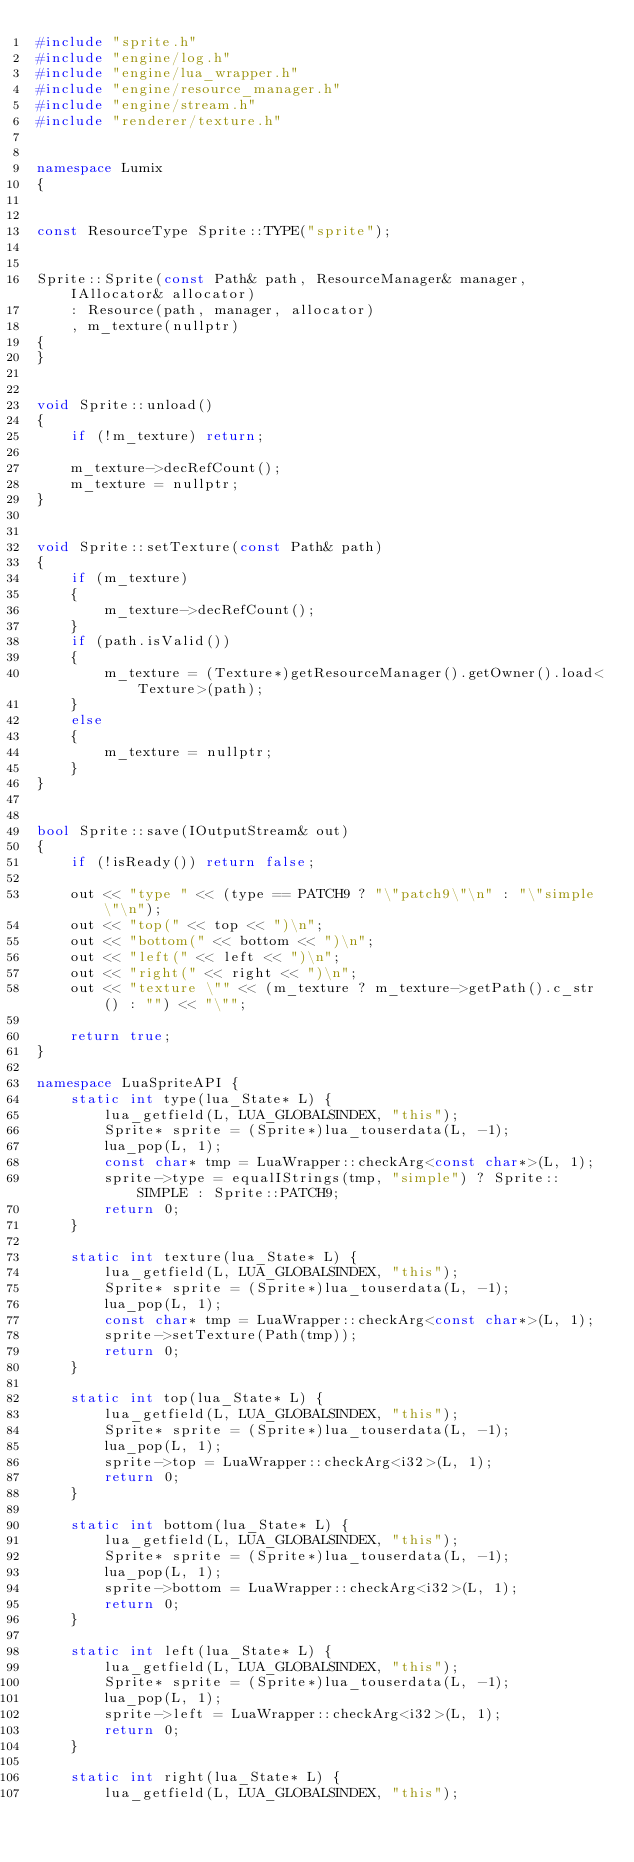Convert code to text. <code><loc_0><loc_0><loc_500><loc_500><_C++_>#include "sprite.h"
#include "engine/log.h"
#include "engine/lua_wrapper.h"
#include "engine/resource_manager.h"
#include "engine/stream.h"
#include "renderer/texture.h"


namespace Lumix
{


const ResourceType Sprite::TYPE("sprite");


Sprite::Sprite(const Path& path, ResourceManager& manager, IAllocator& allocator)
	: Resource(path, manager, allocator)
	, m_texture(nullptr)
{
}


void Sprite::unload()
{
	if (!m_texture) return;
	
	m_texture->decRefCount();
	m_texture = nullptr;
}


void Sprite::setTexture(const Path& path)
{
	if (m_texture)
	{
		m_texture->decRefCount();
	}
	if (path.isValid())
	{
		m_texture = (Texture*)getResourceManager().getOwner().load<Texture>(path);
	}
	else
	{
		m_texture = nullptr;
	}
}


bool Sprite::save(IOutputStream& out)
{
	if (!isReady()) return false;

	out << "type " << (type == PATCH9 ? "\"patch9\"\n" : "\"simple\"\n");
	out << "top(" << top << ")\n";
	out << "bottom(" << bottom << ")\n";
	out << "left(" << left << ")\n";
	out << "right(" << right << ")\n";
	out << "texture \"" << (m_texture ? m_texture->getPath().c_str() : "") << "\"";

	return true;
}

namespace LuaSpriteAPI {
	static int type(lua_State* L) {
		lua_getfield(L, LUA_GLOBALSINDEX, "this");
		Sprite* sprite = (Sprite*)lua_touserdata(L, -1);
		lua_pop(L, 1);
		const char* tmp = LuaWrapper::checkArg<const char*>(L, 1);
		sprite->type = equalIStrings(tmp, "simple") ? Sprite::SIMPLE : Sprite::PATCH9; 
		return 0;
	}

	static int texture(lua_State* L) {
		lua_getfield(L, LUA_GLOBALSINDEX, "this");
		Sprite* sprite = (Sprite*)lua_touserdata(L, -1);
		lua_pop(L, 1);
		const char* tmp = LuaWrapper::checkArg<const char*>(L, 1);
		sprite->setTexture(Path(tmp));
		return 0;
	}

	static int top(lua_State* L) {
		lua_getfield(L, LUA_GLOBALSINDEX, "this");
		Sprite* sprite = (Sprite*)lua_touserdata(L, -1);
		lua_pop(L, 1);
		sprite->top = LuaWrapper::checkArg<i32>(L, 1);
		return 0;
	}

	static int bottom(lua_State* L) {
		lua_getfield(L, LUA_GLOBALSINDEX, "this");
		Sprite* sprite = (Sprite*)lua_touserdata(L, -1);
		lua_pop(L, 1);
		sprite->bottom = LuaWrapper::checkArg<i32>(L, 1);
		return 0;
	}

	static int left(lua_State* L) {
		lua_getfield(L, LUA_GLOBALSINDEX, "this");
		Sprite* sprite = (Sprite*)lua_touserdata(L, -1);
		lua_pop(L, 1);
		sprite->left = LuaWrapper::checkArg<i32>(L, 1);
		return 0;
	}

	static int right(lua_State* L) {
		lua_getfield(L, LUA_GLOBALSINDEX, "this");</code> 